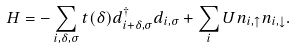<formula> <loc_0><loc_0><loc_500><loc_500>H = - \sum _ { i , \delta , \sigma } t ( \delta ) d ^ { \dagger } _ { i + \delta , \sigma } d _ { i , \sigma } + \sum _ { i } U n _ { i , \uparrow } n _ { i , \downarrow } .</formula> 